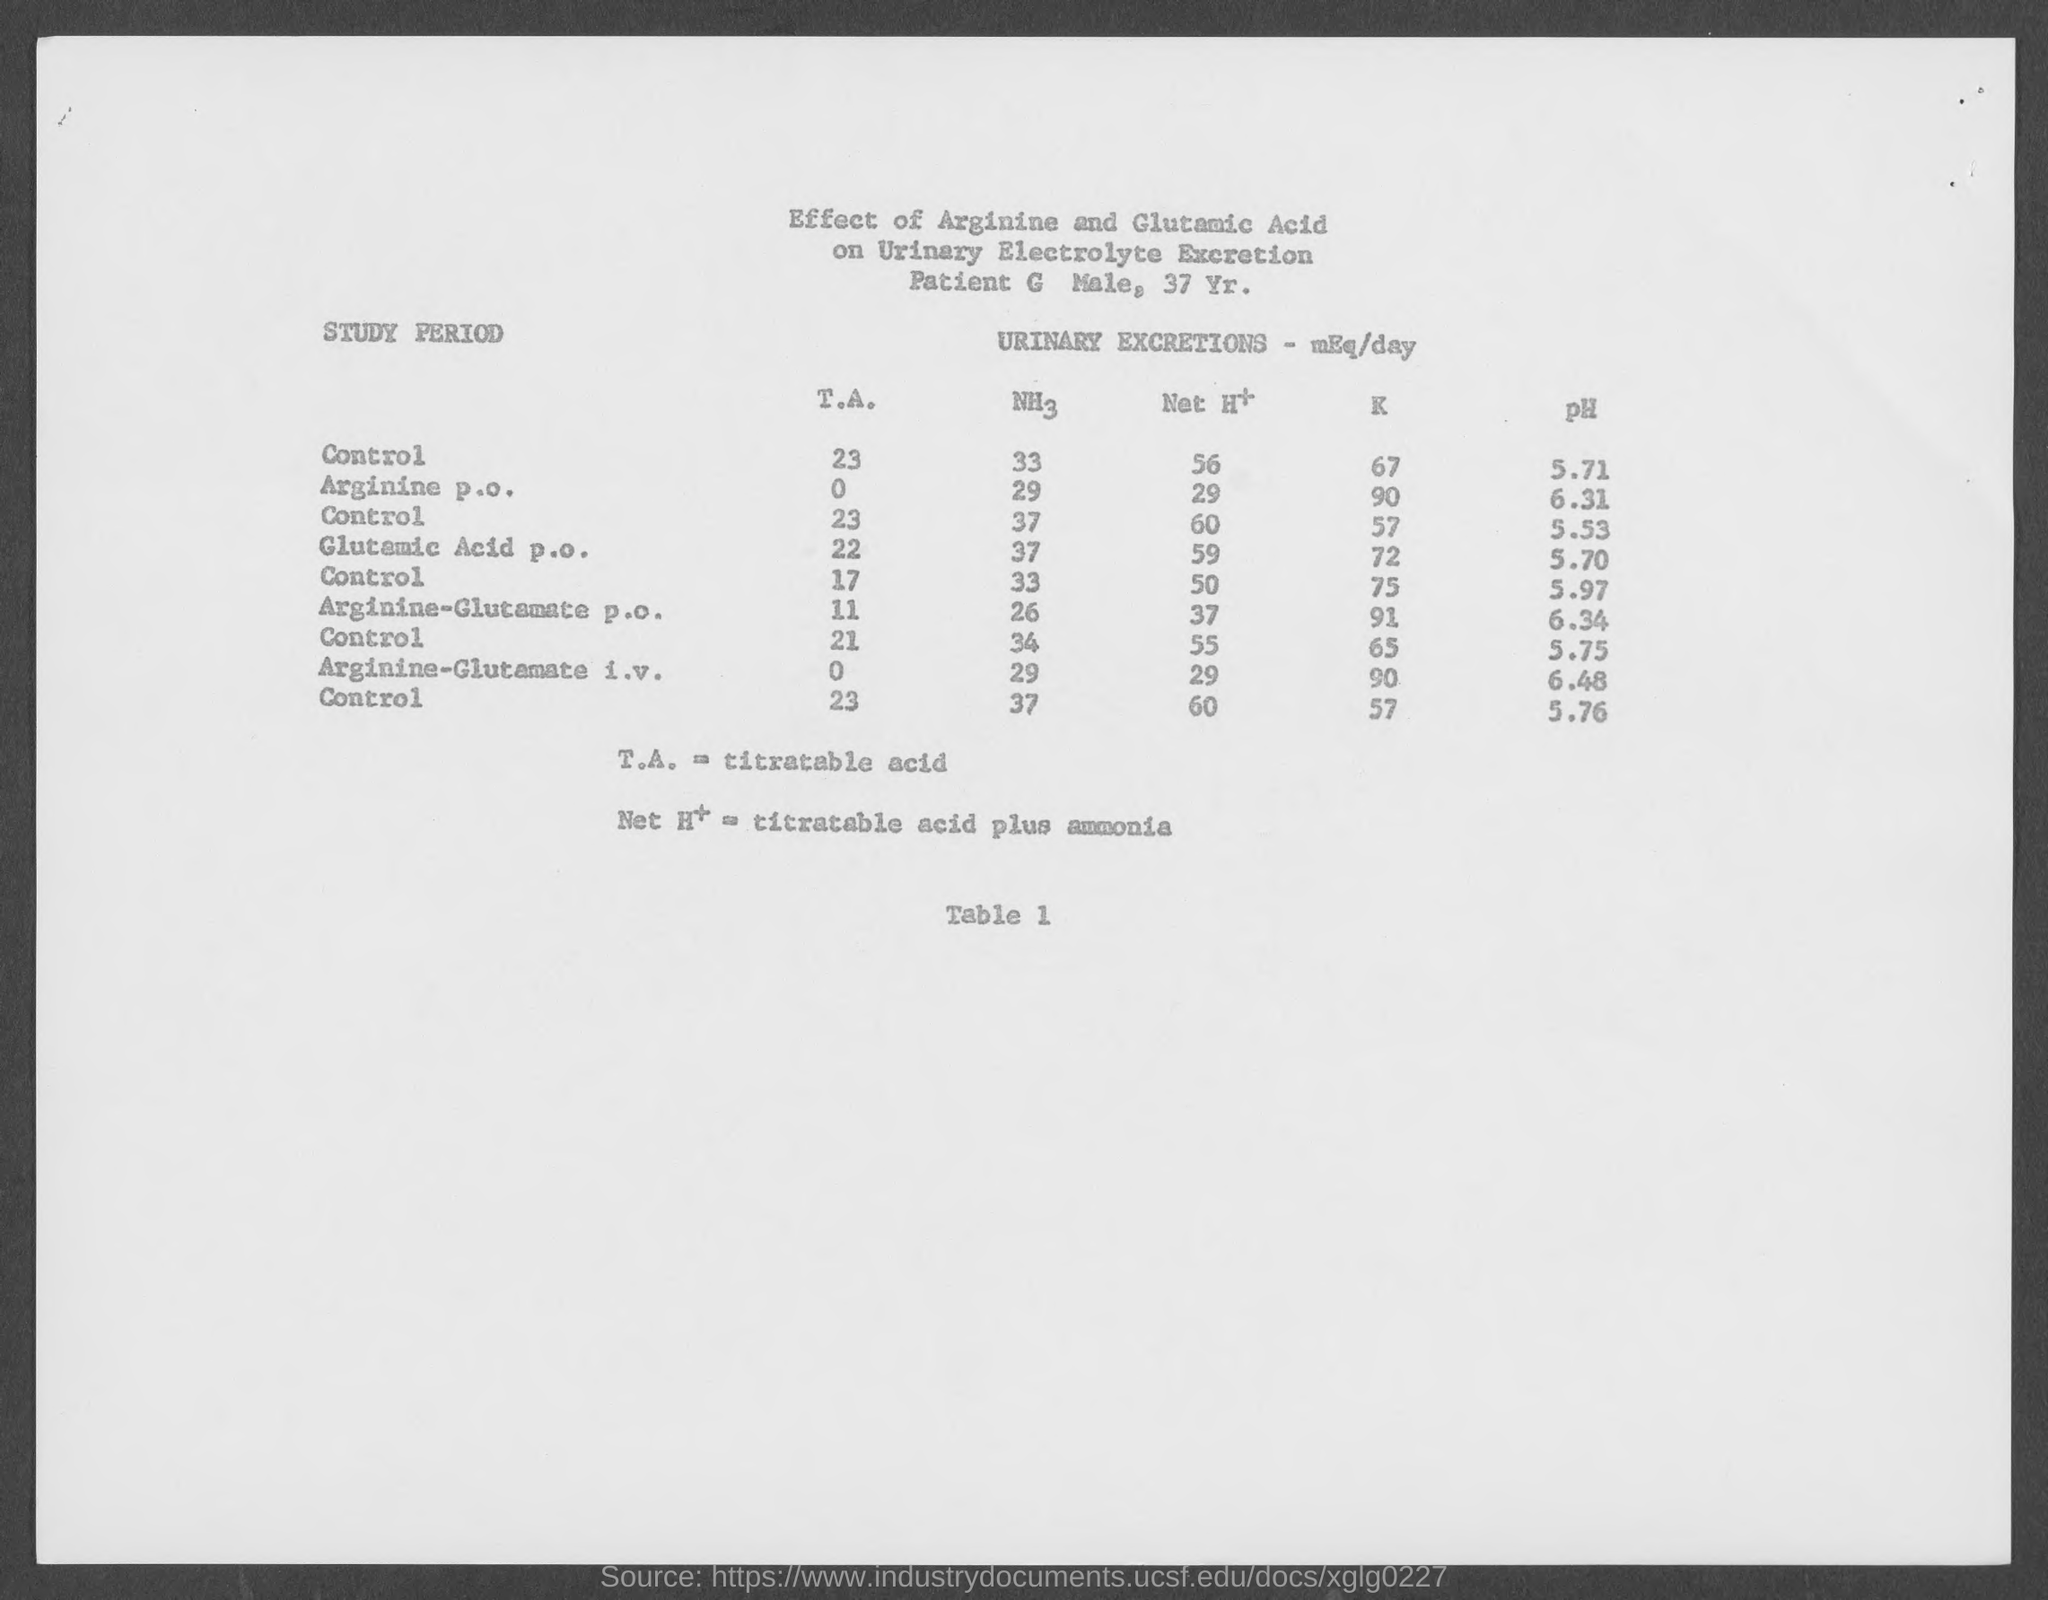Identify some key points in this picture. The pH value of arginine administered orally was found to be 6.31. The pH level of Arginine-Glutamate administered orally is 6.34. The table number is X. It belongs to Table Y. The full form of TA is Titratable Acid. The patient's age is 37 years. 